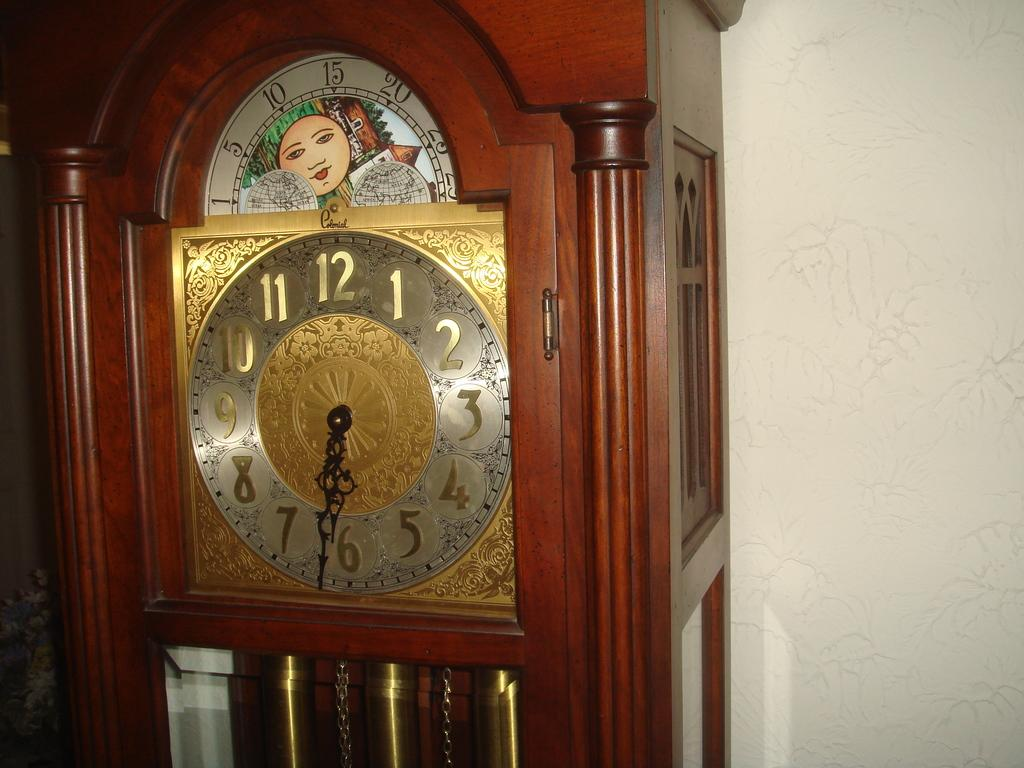<image>
Offer a succinct explanation of the picture presented. Grandfather Clock that has a custom drawing on top and says 6:32 PM. 